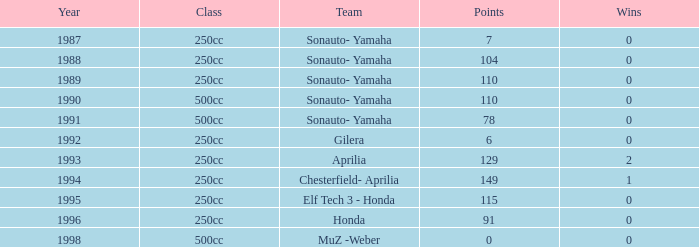Before 1992, what was the greatest amount of points accumulated by a team without any wins? 110.0. 